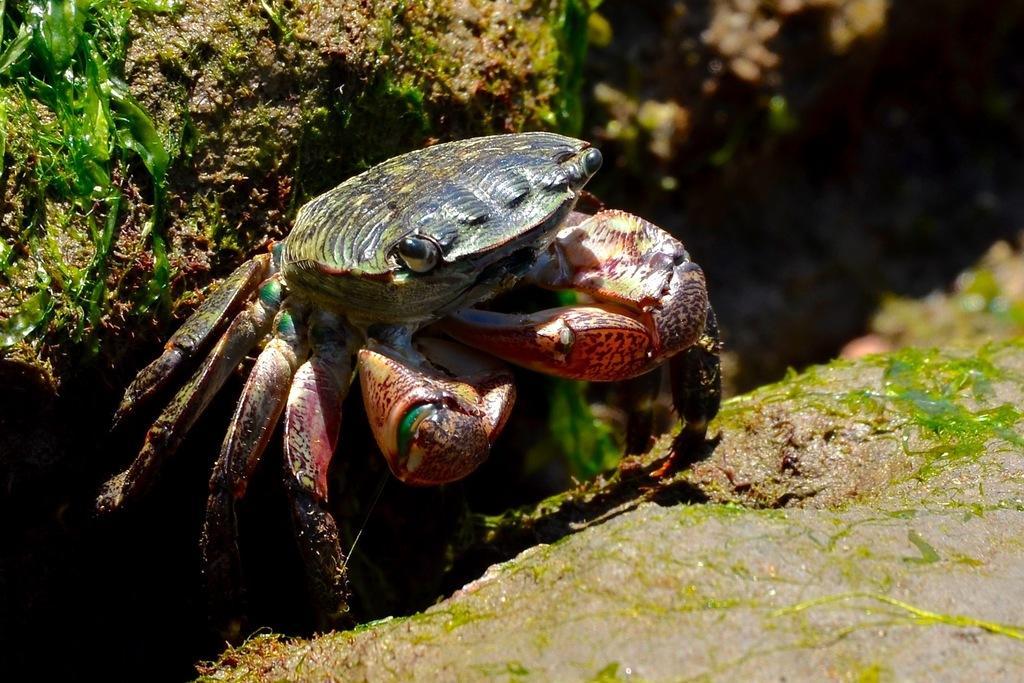Could you give a brief overview of what you see in this image? In this image I can see a crab which is in red,green and black color. Back I can see a green and brown color. 